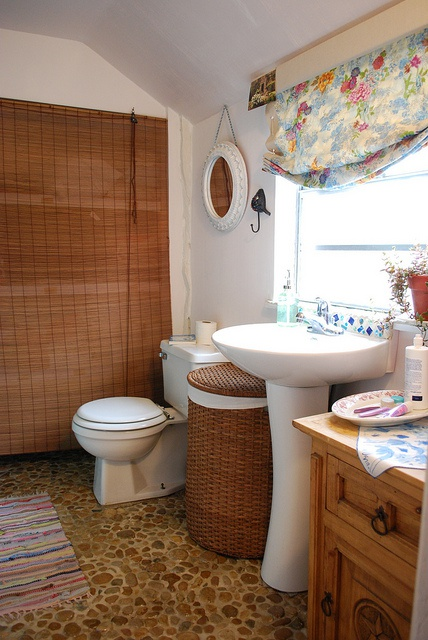Describe the objects in this image and their specific colors. I can see sink in gray, darkgray, and white tones, toilet in gray, darkgray, and lightgray tones, potted plant in gray, white, brown, and darkgray tones, bottle in gray, lightgray, darkgray, and tan tones, and bottle in gray, white, lightblue, and darkgray tones in this image. 